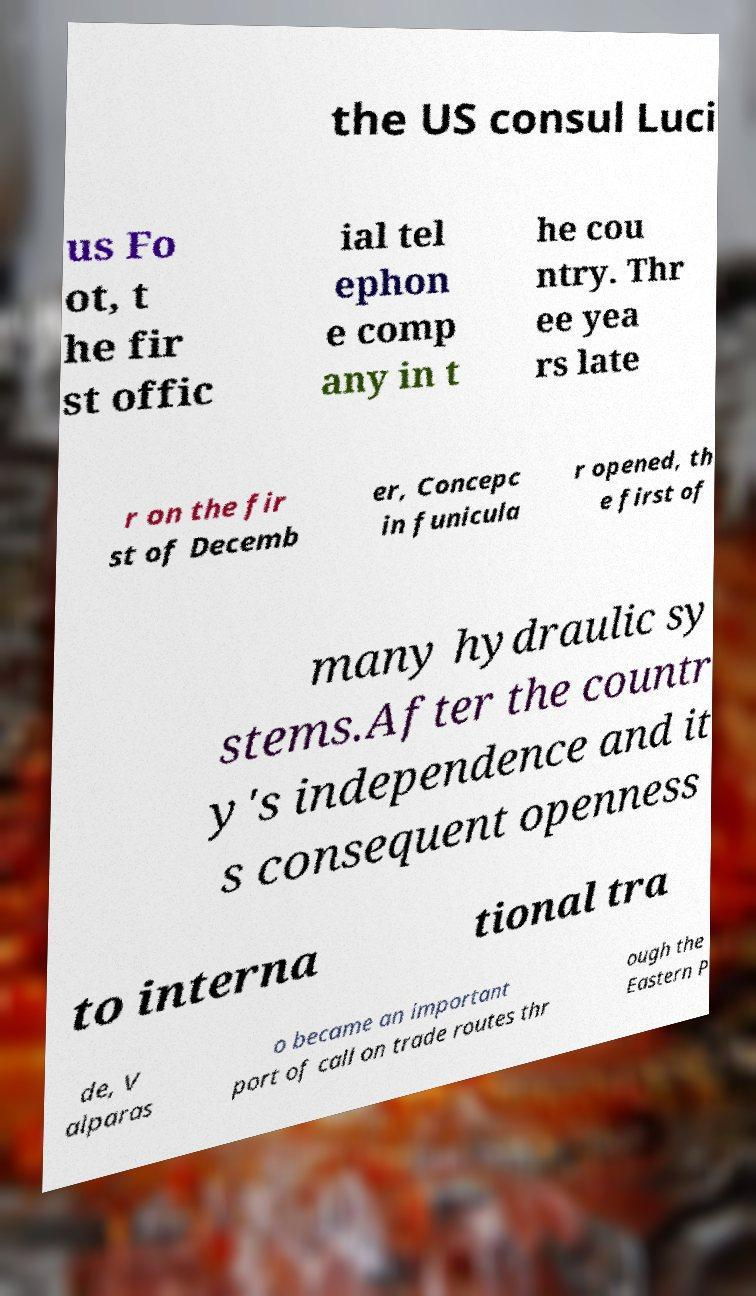Can you accurately transcribe the text from the provided image for me? the US consul Luci us Fo ot, t he fir st offic ial tel ephon e comp any in t he cou ntry. Thr ee yea rs late r on the fir st of Decemb er, Concepc in funicula r opened, th e first of many hydraulic sy stems.After the countr y's independence and it s consequent openness to interna tional tra de, V alparas o became an important port of call on trade routes thr ough the Eastern P 